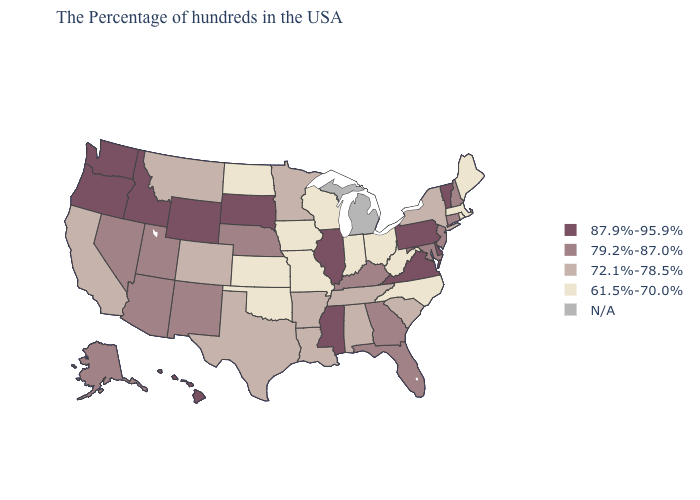What is the highest value in the Northeast ?
Concise answer only. 87.9%-95.9%. Which states have the lowest value in the USA?
Answer briefly. Maine, Massachusetts, Rhode Island, North Carolina, West Virginia, Ohio, Indiana, Wisconsin, Missouri, Iowa, Kansas, Oklahoma, North Dakota. Among the states that border Texas , which have the highest value?
Be succinct. New Mexico. Name the states that have a value in the range N/A?
Keep it brief. Michigan. What is the highest value in the USA?
Answer briefly. 87.9%-95.9%. Name the states that have a value in the range 61.5%-70.0%?
Short answer required. Maine, Massachusetts, Rhode Island, North Carolina, West Virginia, Ohio, Indiana, Wisconsin, Missouri, Iowa, Kansas, Oklahoma, North Dakota. Name the states that have a value in the range 61.5%-70.0%?
Answer briefly. Maine, Massachusetts, Rhode Island, North Carolina, West Virginia, Ohio, Indiana, Wisconsin, Missouri, Iowa, Kansas, Oklahoma, North Dakota. Does South Dakota have the highest value in the USA?
Short answer required. Yes. Name the states that have a value in the range N/A?
Write a very short answer. Michigan. What is the value of Idaho?
Be succinct. 87.9%-95.9%. Among the states that border Georgia , does South Carolina have the highest value?
Give a very brief answer. No. Does New Jersey have the lowest value in the USA?
Give a very brief answer. No. How many symbols are there in the legend?
Quick response, please. 5. 